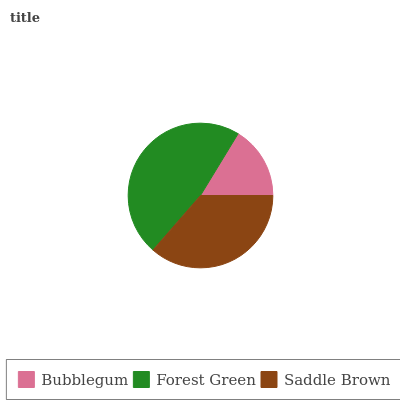Is Bubblegum the minimum?
Answer yes or no. Yes. Is Forest Green the maximum?
Answer yes or no. Yes. Is Saddle Brown the minimum?
Answer yes or no. No. Is Saddle Brown the maximum?
Answer yes or no. No. Is Forest Green greater than Saddle Brown?
Answer yes or no. Yes. Is Saddle Brown less than Forest Green?
Answer yes or no. Yes. Is Saddle Brown greater than Forest Green?
Answer yes or no. No. Is Forest Green less than Saddle Brown?
Answer yes or no. No. Is Saddle Brown the high median?
Answer yes or no. Yes. Is Saddle Brown the low median?
Answer yes or no. Yes. Is Forest Green the high median?
Answer yes or no. No. Is Forest Green the low median?
Answer yes or no. No. 